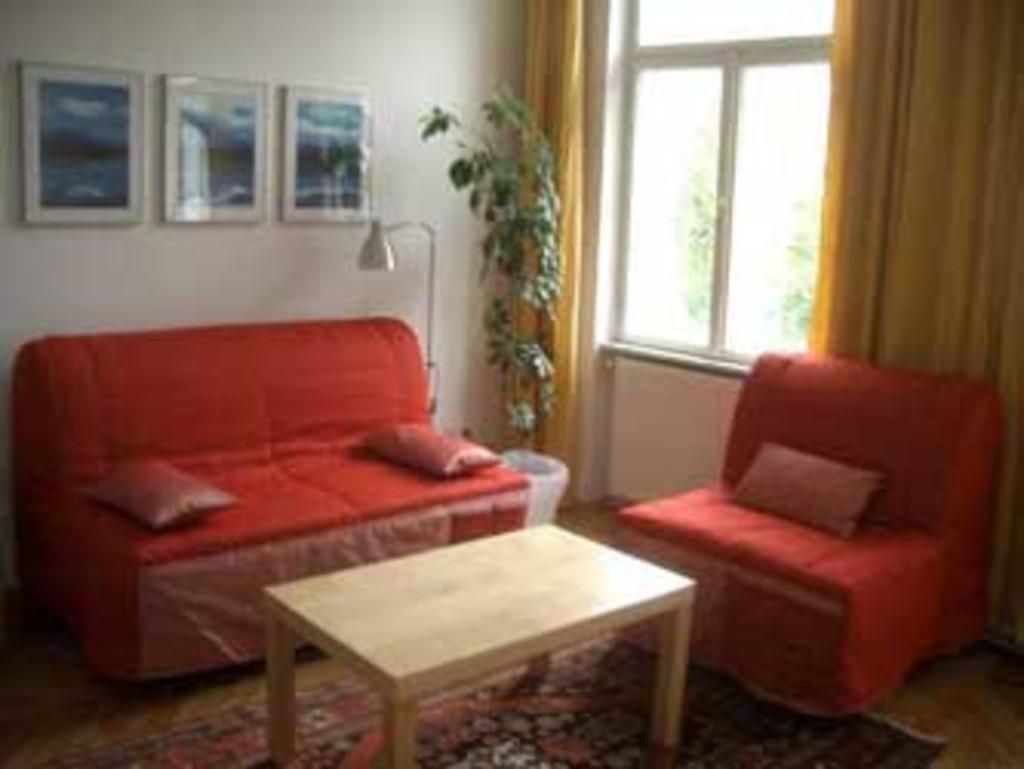Please provide a concise description of this image. In this image I see a sofa set, a table, plant. In the background I see the wall, window, curtains and the photo frames. 